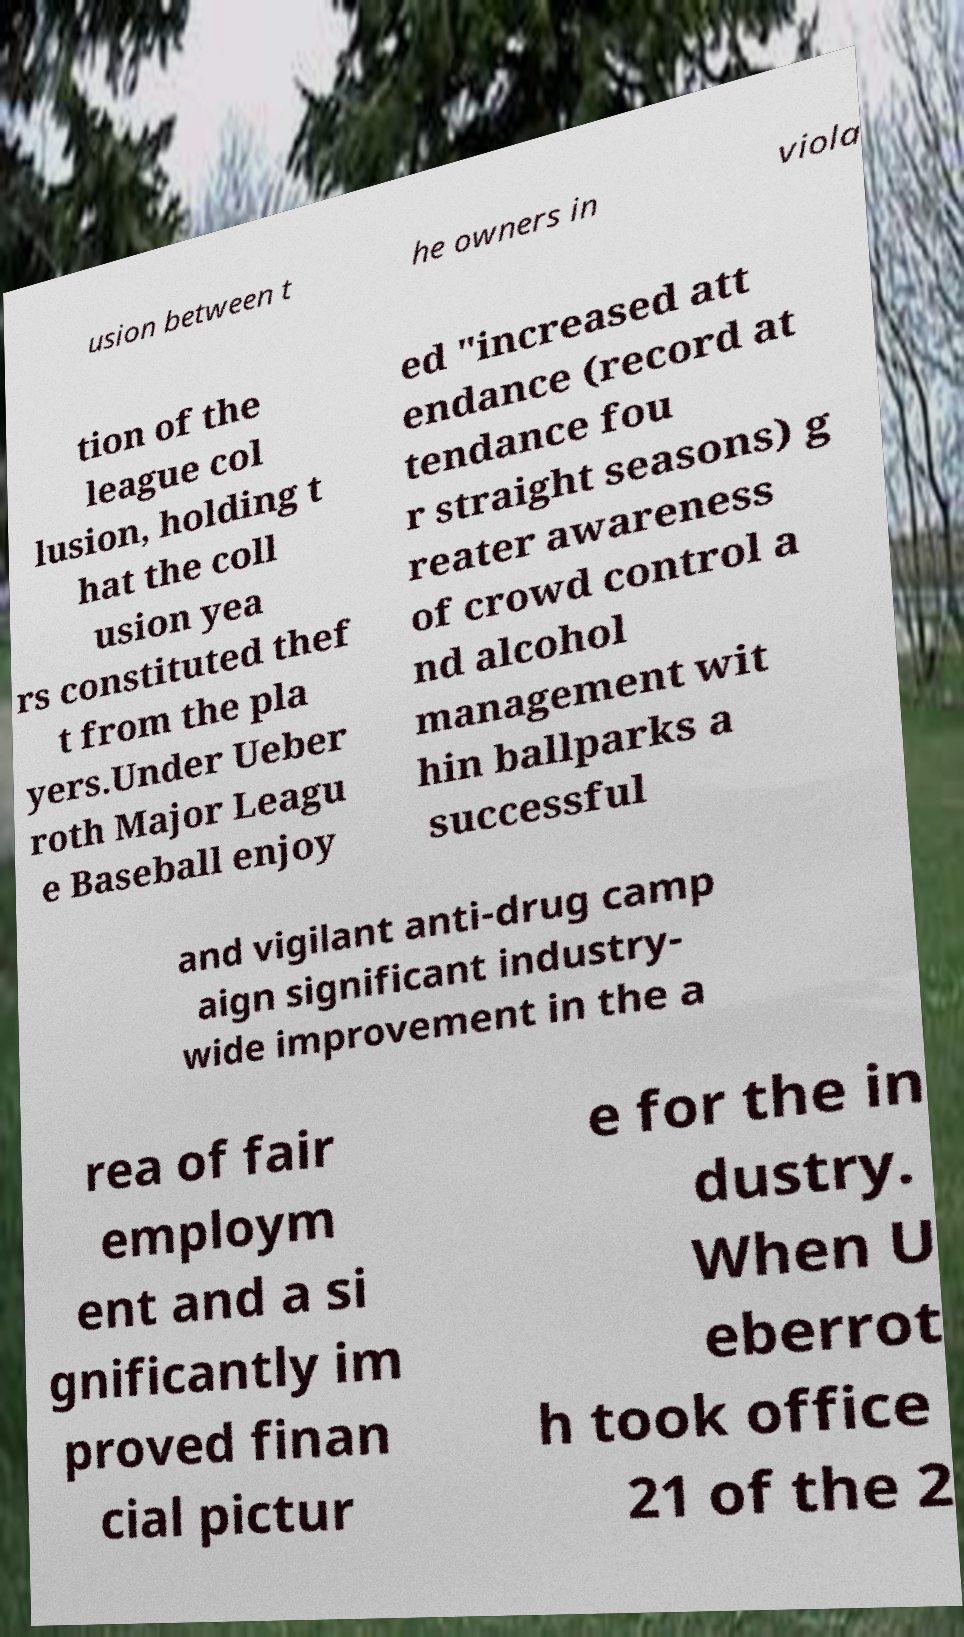Can you read and provide the text displayed in the image?This photo seems to have some interesting text. Can you extract and type it out for me? usion between t he owners in viola tion of the league col lusion, holding t hat the coll usion yea rs constituted thef t from the pla yers.Under Ueber roth Major Leagu e Baseball enjoy ed "increased att endance (record at tendance fou r straight seasons) g reater awareness of crowd control a nd alcohol management wit hin ballparks a successful and vigilant anti-drug camp aign significant industry- wide improvement in the a rea of fair employm ent and a si gnificantly im proved finan cial pictur e for the in dustry. When U eberrot h took office 21 of the 2 